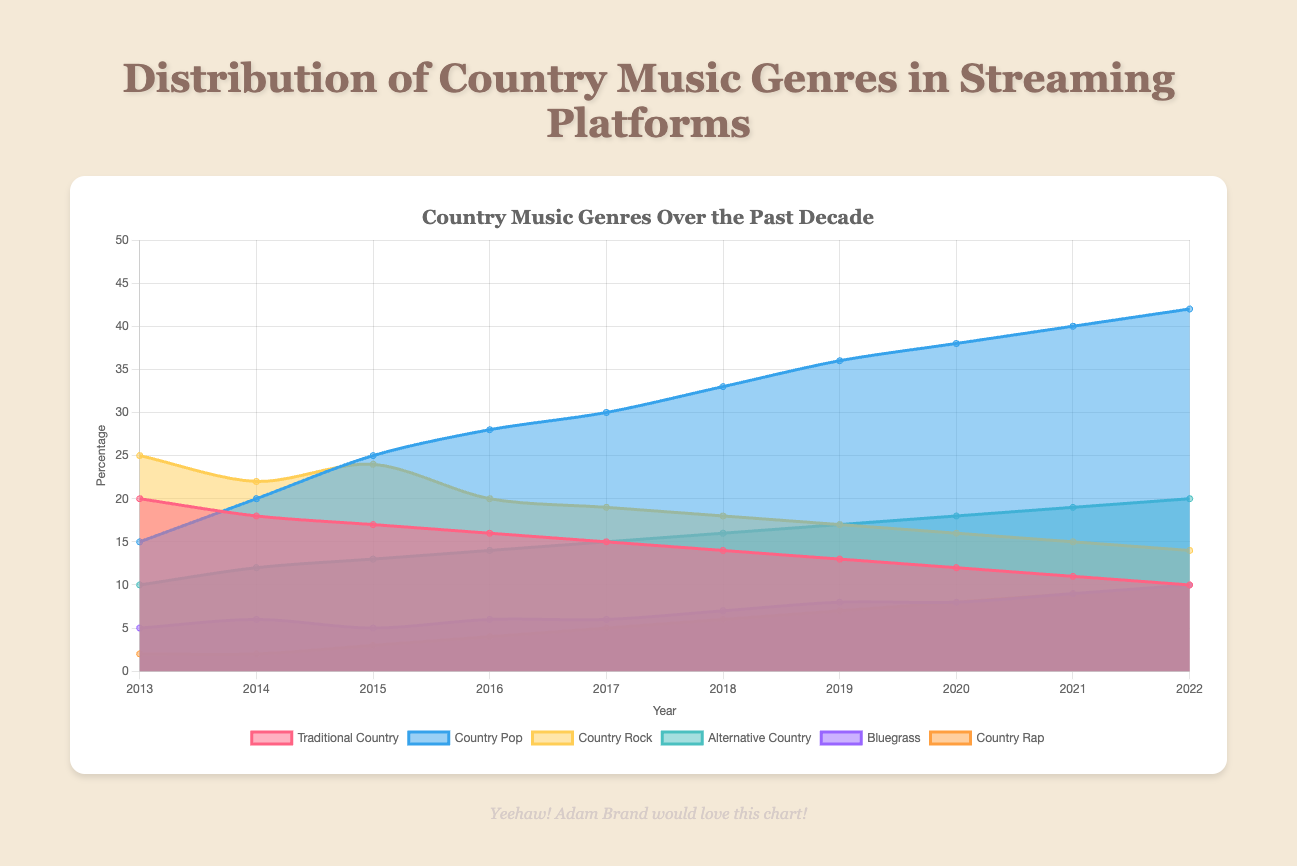What is the title of the chart? The title is positioned at the top of the chart and is visible as the main heading.
Answer: Country Music Genres Over the Past Decade Which country music genre had the highest percentage in 2013? By examining the chart and looking at the year 2013, the highest value is for Country Rock at 25%.
Answer: Country Rock How many country music genres are represented in the chart? The chart legend shows six different genres: Traditional Country, Country Pop, Country Rock, Alternative Country, Bluegrass, and Country Rap.
Answer: Six What trend do you notice for Traditional Country between 2013 and 2022? Traditional Country shows a clear declining trend as the area representing it shrinks from 20% in 2013 to 10% in 2022.
Answer: Declining Compare the growth of Country Pop and Country Rap from 2013 to 2022. Country Pop increases from 15% to 42%, while Country Rap grows from 2% to 10%. Both genres show significant growth, but Country Pop has the larger absolute increase.
Answer: Both increased; Country Pop had a larger increase Which year did Alternative Country surpass Traditional Country in popularity? By examining the points where the areas of Alternative Country and Traditional Country intersect, 2018 is the first year Alternative Country surpasses Traditional Country.
Answer: 2018 What was the percentage of Bluegrass in 2019? Reference the chart at the year 2019; the value for Bluegrass is 8%.
Answer: 8% What is the total percentage of Country Rock across all years? Summing the percentages for Country Rock from 2013 to 2022: 25+22+24+20+19+18+17+16+15+14 = 190%.
Answer: 190% Which genre shows the smallest overall change in percentage from 2013 to 2022? Comparing the first and last year values for each genre, Bluegrass goes from 5% to 10%, a change of 5 percentage points, the smallest change among all genres.
Answer: Bluegrass In which year did Country Pop become the dominant genre? The area for Country Pop grows the largest and overtakes all other genres by 2016.
Answer: 2016 